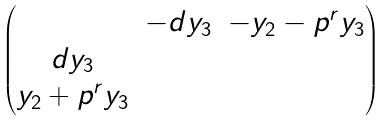<formula> <loc_0><loc_0><loc_500><loc_500>\begin{pmatrix} & - d y _ { 3 } & - y _ { 2 } - p ^ { r } y _ { 3 } \\ d y _ { 3 } & & \\ y _ { 2 } + p ^ { r } y _ { 3 } & & \end{pmatrix}</formula> 